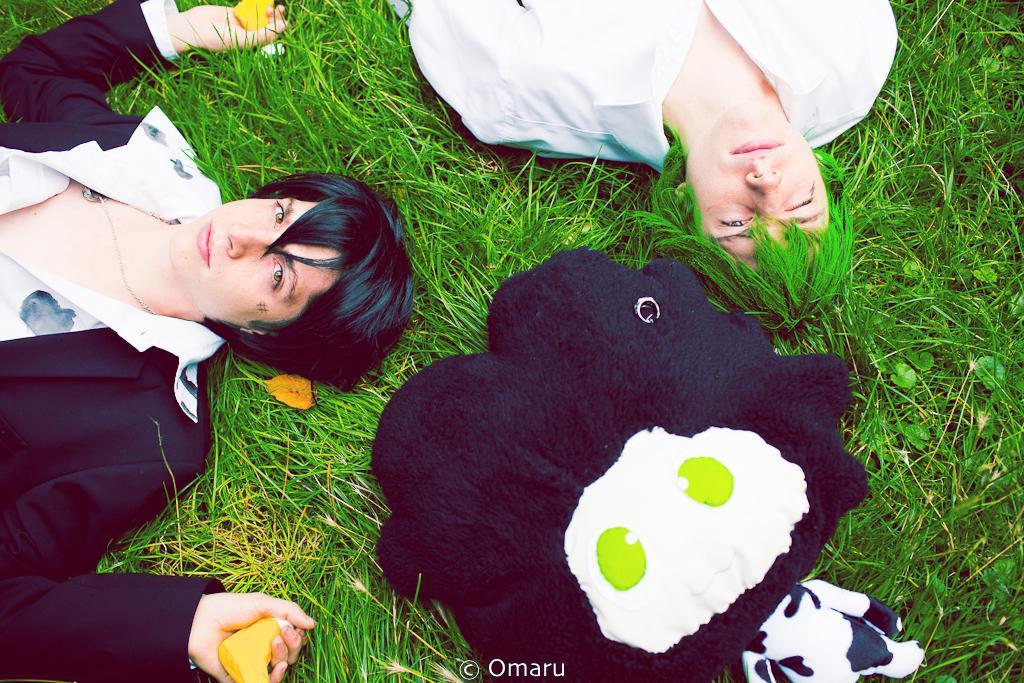In one or two sentences, can you explain what this image depicts? In this image there is one person lying on a grass at left side of this image and there is one another person is at top of this image. There is one toy at bottom of this image and as we can see there is some grass in the background. 